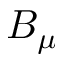Convert formula to latex. <formula><loc_0><loc_0><loc_500><loc_500>B _ { \mu }</formula> 